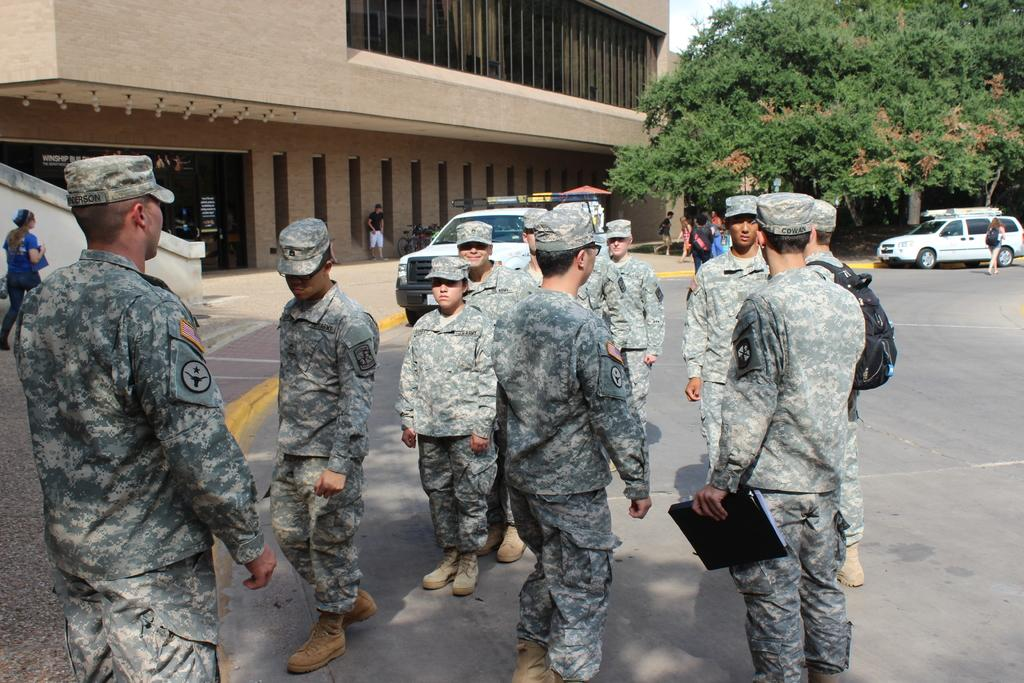What are the people in the image doing? The people in the image are standing and walking. What are the people holding in their hands? The people are holding something in their hands. What can be seen in the background of the image? There are vehicles, trees, and buildings visible in the background of the image. What type of paint is being used by the people in the image? There is no paint visible in the image, and the people are not using any paint. 